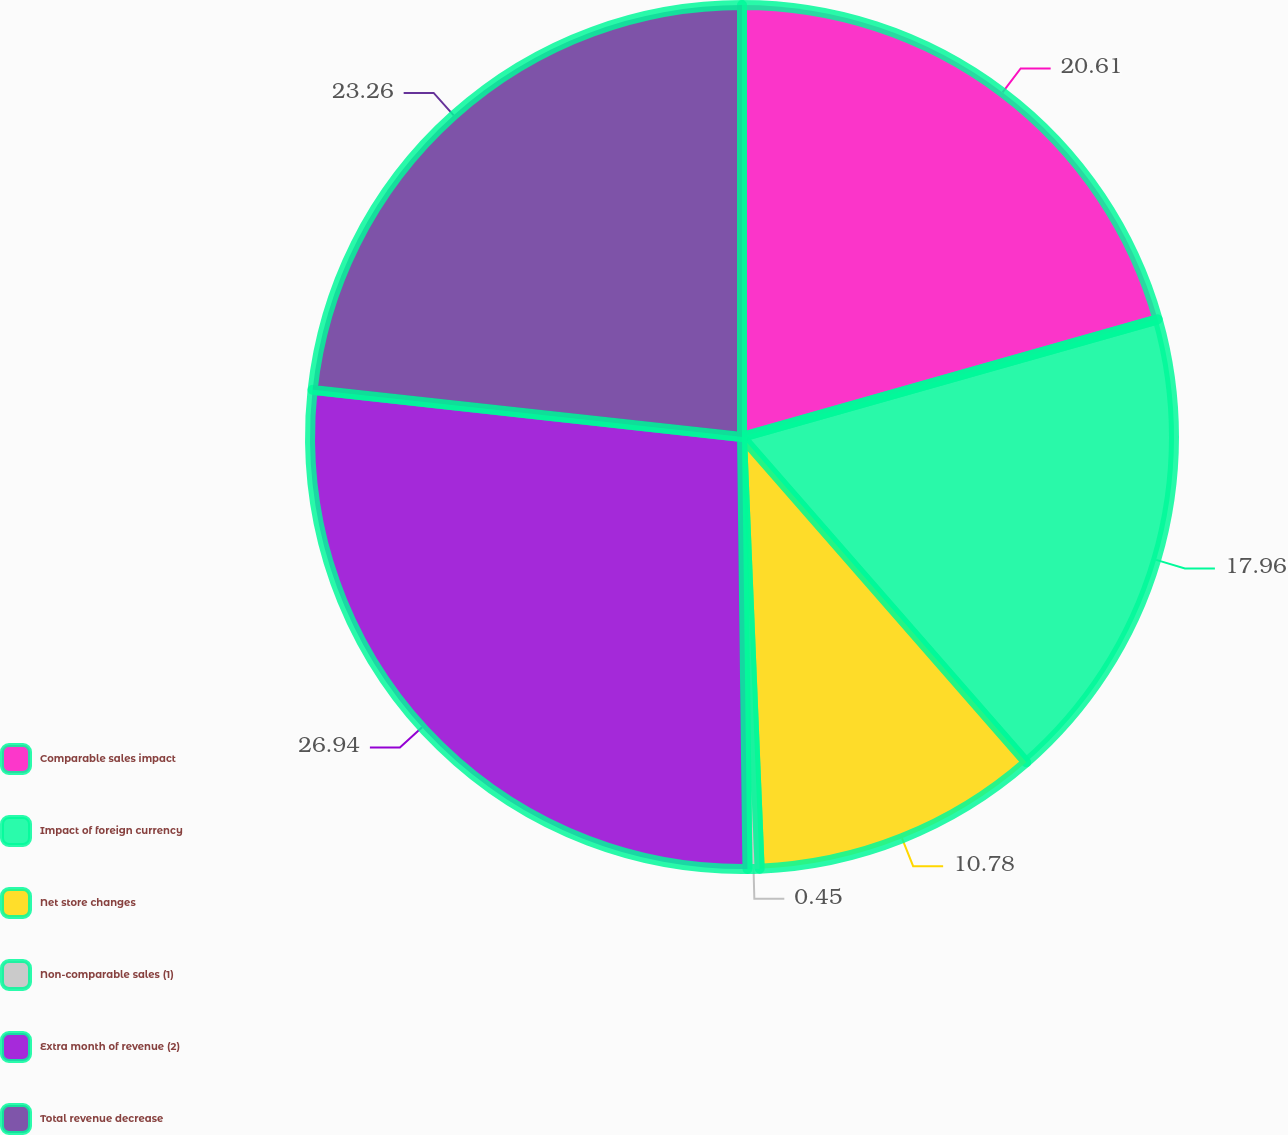Convert chart. <chart><loc_0><loc_0><loc_500><loc_500><pie_chart><fcel>Comparable sales impact<fcel>Impact of foreign currency<fcel>Net store changes<fcel>Non-comparable sales (1)<fcel>Extra month of revenue (2)<fcel>Total revenue decrease<nl><fcel>20.61%<fcel>17.96%<fcel>10.78%<fcel>0.45%<fcel>26.94%<fcel>23.26%<nl></chart> 